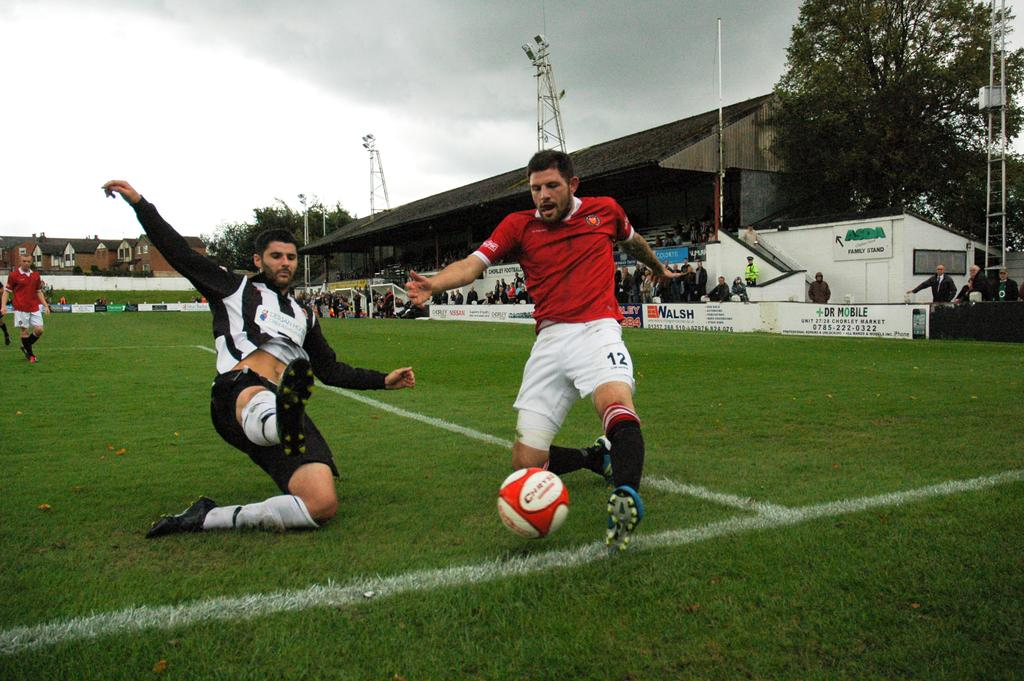Provide a one-sentence caption for the provided image. Two men are playing soccer on a field that is sponsored by Dr. Mobile, Asda, and Nissan. 